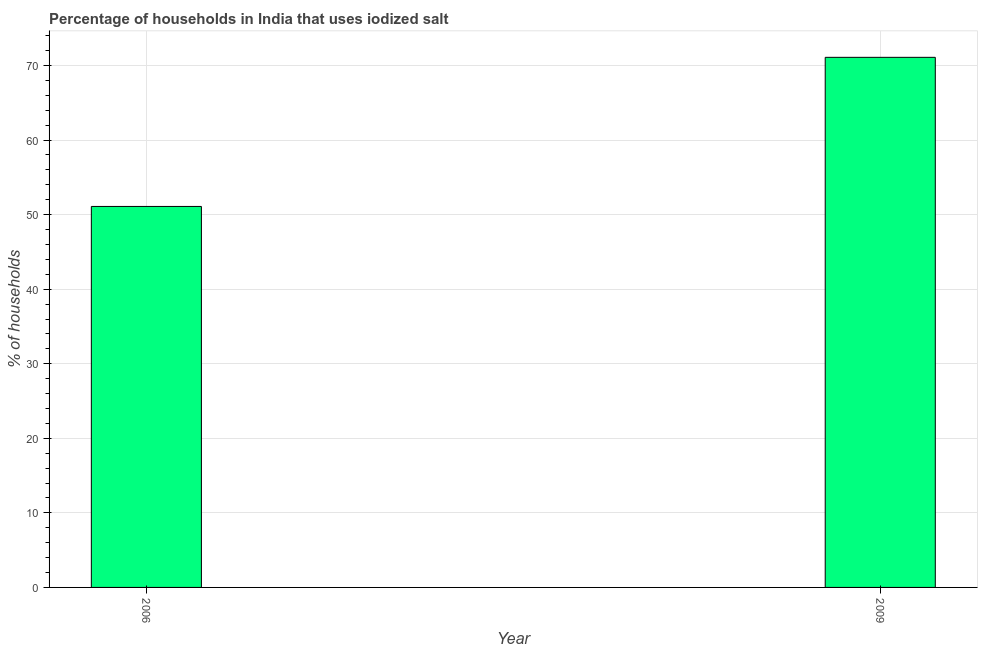What is the title of the graph?
Provide a succinct answer. Percentage of households in India that uses iodized salt. What is the label or title of the X-axis?
Offer a very short reply. Year. What is the label or title of the Y-axis?
Offer a terse response. % of households. What is the percentage of households where iodized salt is consumed in 2009?
Provide a succinct answer. 71.1. Across all years, what is the maximum percentage of households where iodized salt is consumed?
Ensure brevity in your answer.  71.1. Across all years, what is the minimum percentage of households where iodized salt is consumed?
Make the answer very short. 51.1. In which year was the percentage of households where iodized salt is consumed minimum?
Offer a very short reply. 2006. What is the sum of the percentage of households where iodized salt is consumed?
Give a very brief answer. 122.2. What is the average percentage of households where iodized salt is consumed per year?
Your response must be concise. 61.1. What is the median percentage of households where iodized salt is consumed?
Provide a short and direct response. 61.1. In how many years, is the percentage of households where iodized salt is consumed greater than 60 %?
Offer a very short reply. 1. What is the ratio of the percentage of households where iodized salt is consumed in 2006 to that in 2009?
Give a very brief answer. 0.72. Is the percentage of households where iodized salt is consumed in 2006 less than that in 2009?
Offer a terse response. Yes. In how many years, is the percentage of households where iodized salt is consumed greater than the average percentage of households where iodized salt is consumed taken over all years?
Your answer should be very brief. 1. How many bars are there?
Your answer should be compact. 2. How many years are there in the graph?
Offer a very short reply. 2. What is the difference between two consecutive major ticks on the Y-axis?
Ensure brevity in your answer.  10. What is the % of households in 2006?
Offer a terse response. 51.1. What is the % of households in 2009?
Provide a short and direct response. 71.1. What is the ratio of the % of households in 2006 to that in 2009?
Make the answer very short. 0.72. 